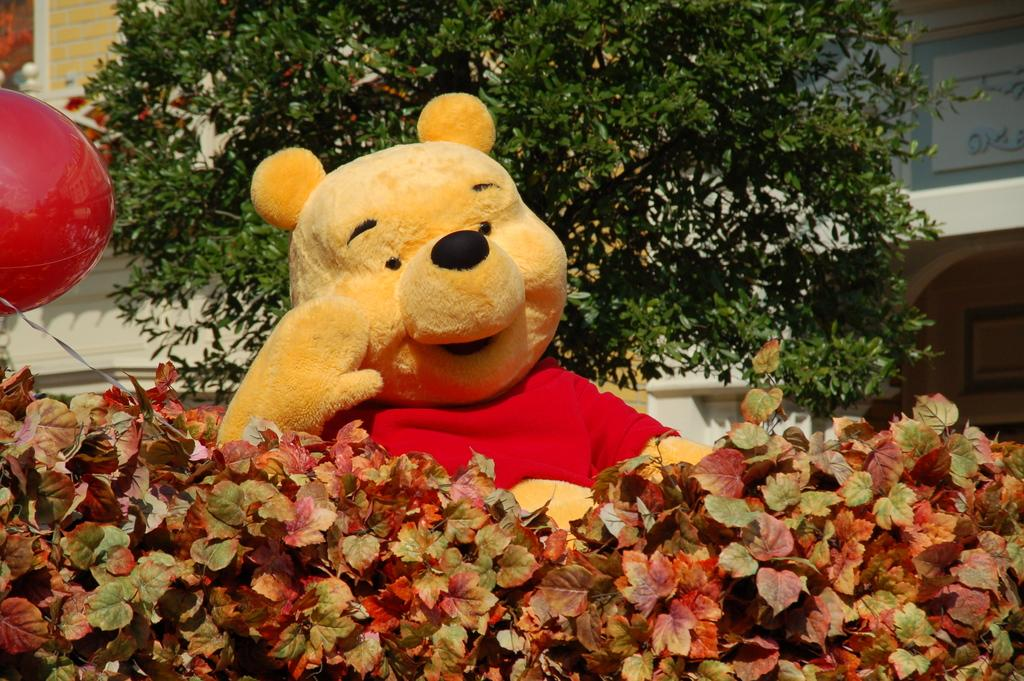What is located in the foreground of the image? There are plants and a toy in the foreground of the image. What can be seen in the background of the image? It appears that there is a house and a tree in the background of the image. How many cows are visible on the side of the house in the image? There are no cows present in the image. What type of son is playing with the toy in the foreground of the image? There is no son present in the image; it only shows a toy and plants in the foreground. 